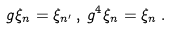<formula> <loc_0><loc_0><loc_500><loc_500>g \xi _ { n } = \xi _ { n ^ { \prime } } \, , \, g ^ { 4 } \xi _ { n } = \xi _ { n } \, .</formula> 